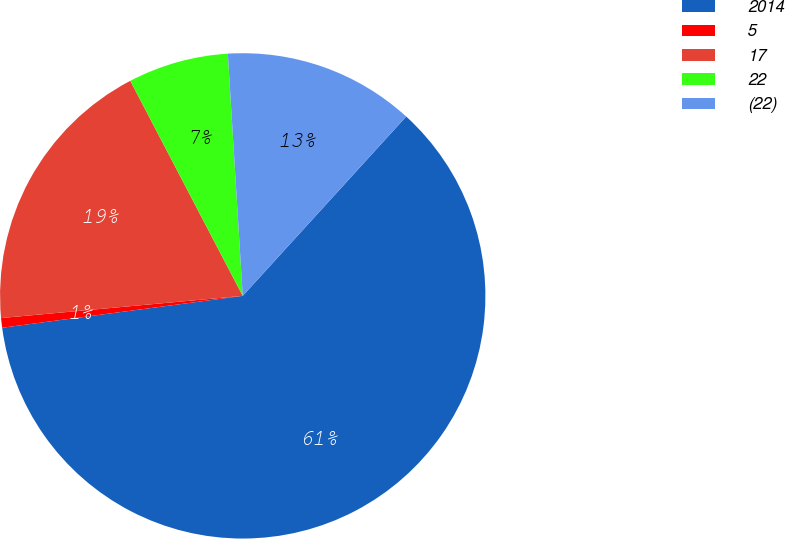Convert chart to OTSL. <chart><loc_0><loc_0><loc_500><loc_500><pie_chart><fcel>2014<fcel>5<fcel>17<fcel>22<fcel>(22)<nl><fcel>61.14%<fcel>0.64%<fcel>18.79%<fcel>6.69%<fcel>12.74%<nl></chart> 